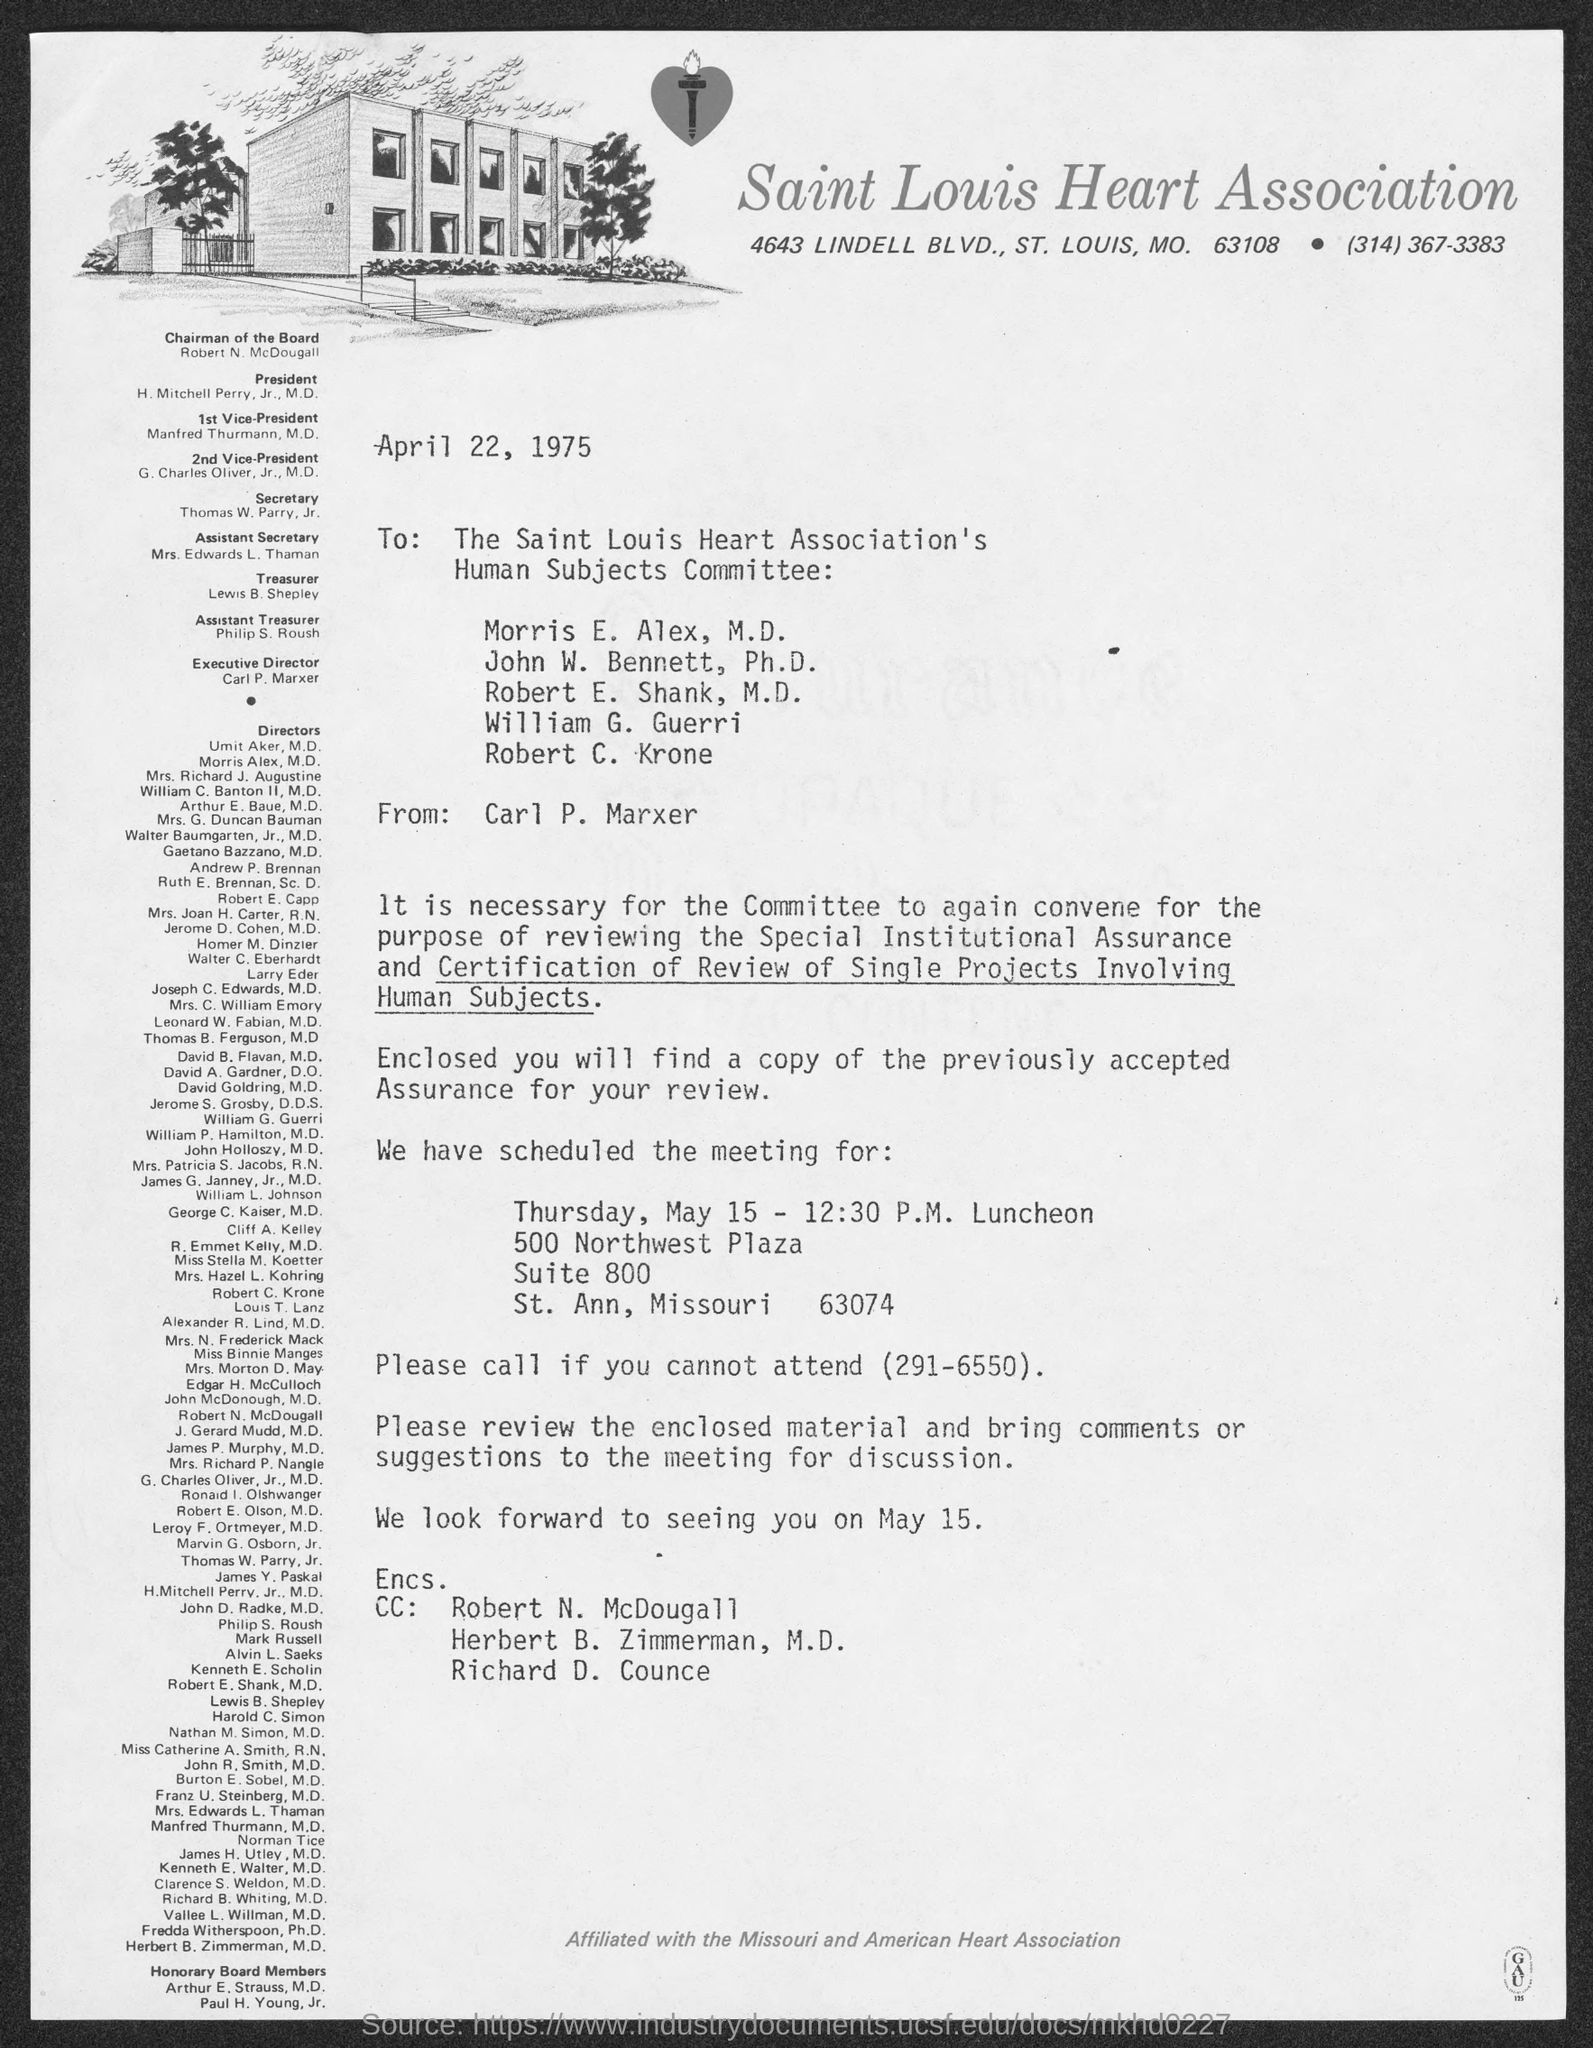Indicate a few pertinent items in this graphic. The street address of the Saint Louis Heart Association is located at 4643 Lindell Blvd. Lewis B. Shepley is the Treasurer. Mrs. Edwards L. Thaman holds the position of Assistant Secretary. The President is H. Mitchell Perry, Jr., M.D. The chairman of the Board is Robert N. McDougall. 